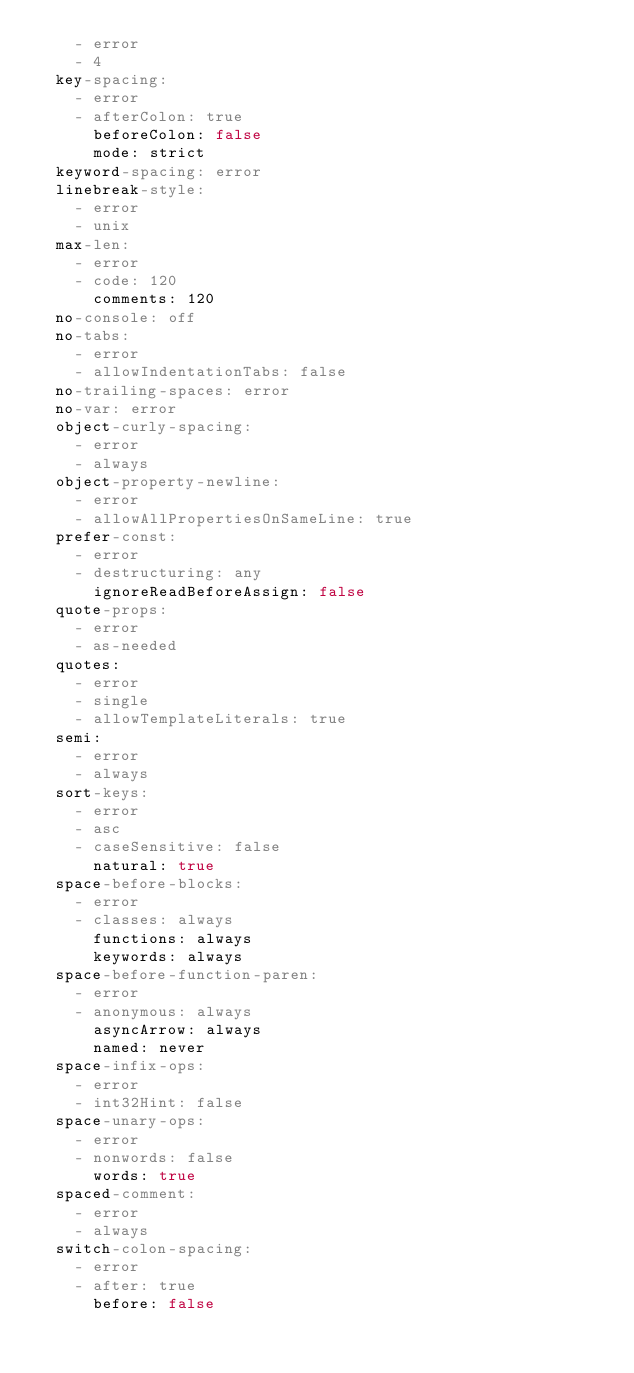<code> <loc_0><loc_0><loc_500><loc_500><_YAML_>    - error
    - 4
  key-spacing:
    - error
    - afterColon: true
      beforeColon: false
      mode: strict
  keyword-spacing: error
  linebreak-style:
    - error
    - unix
  max-len:
    - error
    - code: 120
      comments: 120
  no-console: off
  no-tabs:
    - error
    - allowIndentationTabs: false
  no-trailing-spaces: error
  no-var: error
  object-curly-spacing:
    - error
    - always
  object-property-newline:
    - error
    - allowAllPropertiesOnSameLine: true
  prefer-const:
    - error
    - destructuring: any
      ignoreReadBeforeAssign: false
  quote-props:
    - error
    - as-needed
  quotes:
    - error
    - single
    - allowTemplateLiterals: true
  semi:
    - error
    - always
  sort-keys:
    - error
    - asc
    - caseSensitive: false
      natural: true
  space-before-blocks:
    - error
    - classes: always
      functions: always
      keywords: always
  space-before-function-paren:
    - error
    - anonymous: always
      asyncArrow: always
      named: never
  space-infix-ops:
    - error
    - int32Hint: false
  space-unary-ops:
    - error
    - nonwords: false
      words: true
  spaced-comment:
    - error
    - always
  switch-colon-spacing:
    - error
    - after: true
      before: false
</code> 